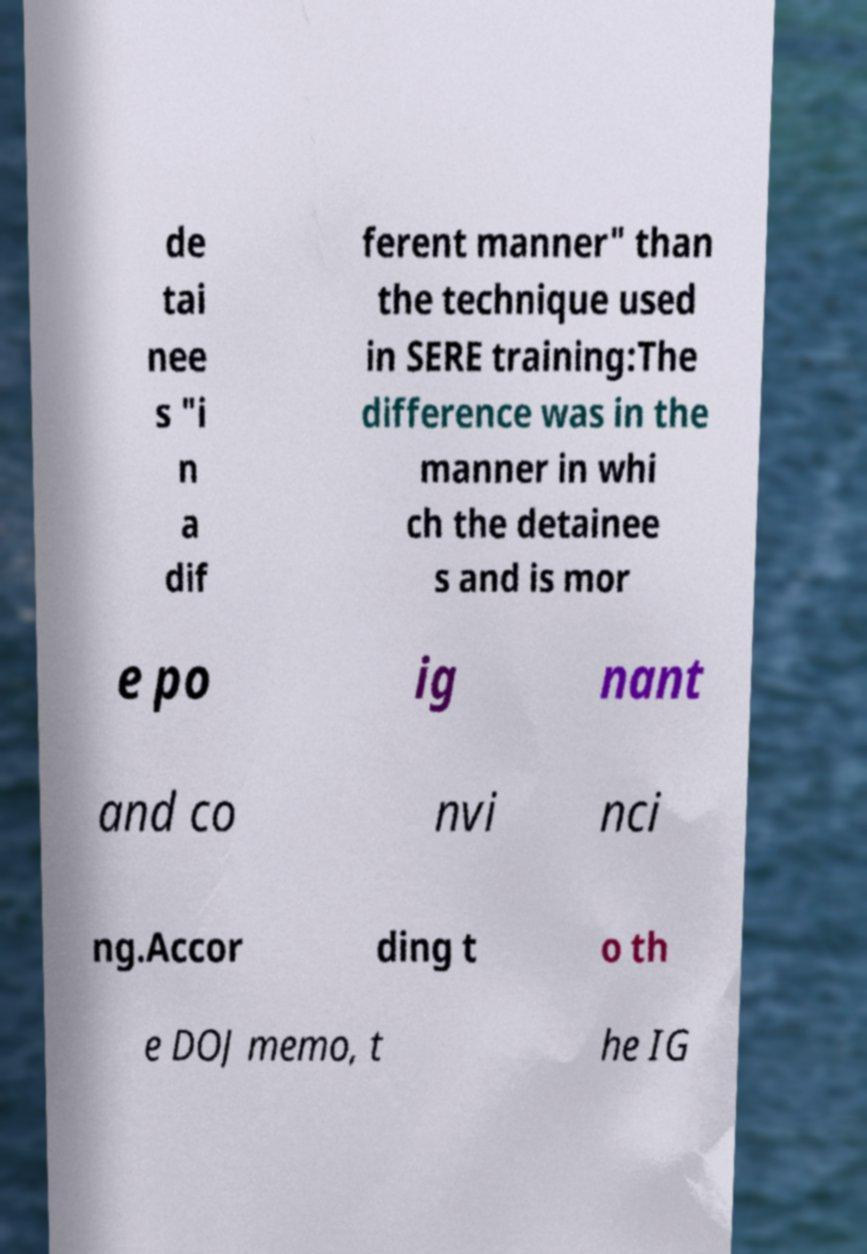What messages or text are displayed in this image? I need them in a readable, typed format. de tai nee s "i n a dif ferent manner" than the technique used in SERE training:The difference was in the manner in whi ch the detainee s and is mor e po ig nant and co nvi nci ng.Accor ding t o th e DOJ memo, t he IG 